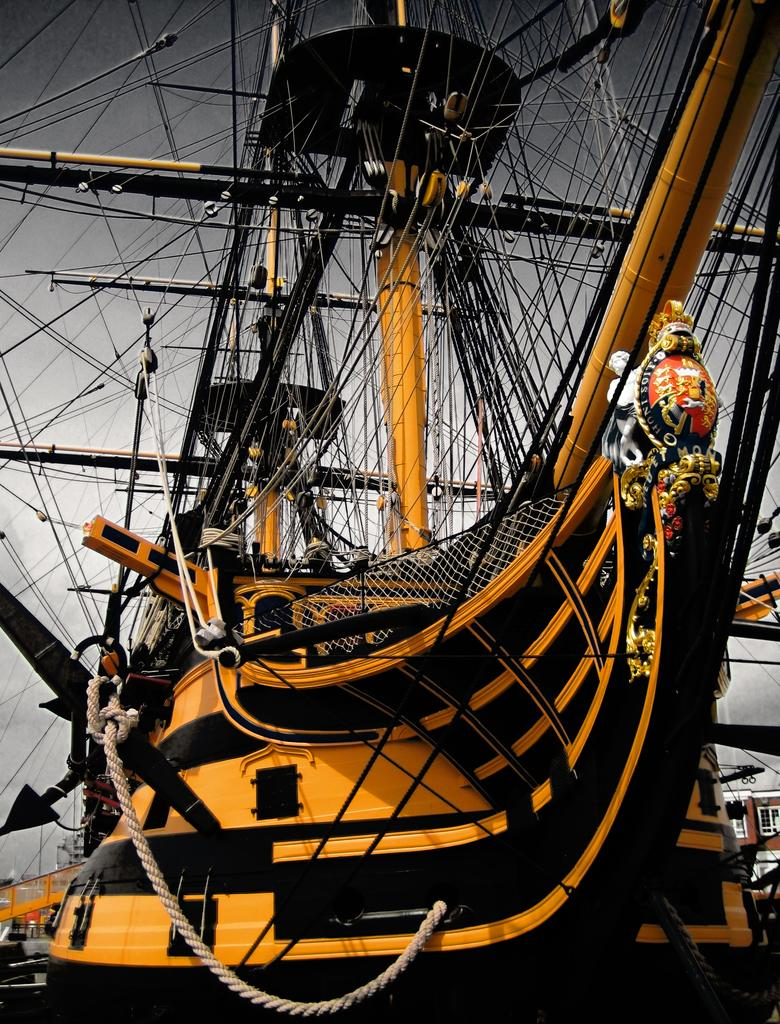What is the main subject of the image? The main subject of the image is a ship. What colors are used to paint the ship? The ship is colored black and yellow. How many clams are visible on the ship's deck in the image? There are no clams visible on the ship's deck in the image. 